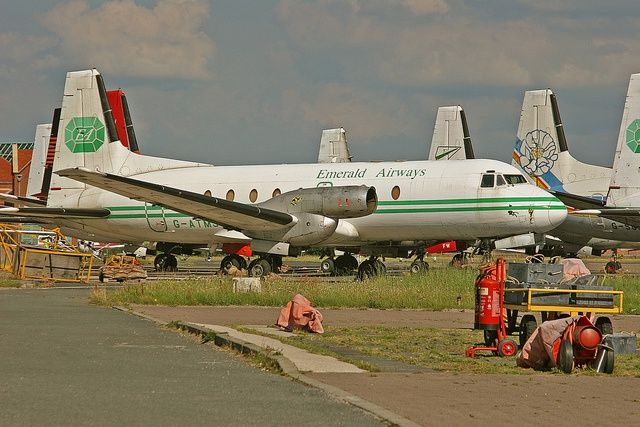Describe the objects in this image and their specific colors. I can see airplane in gray, lightgray, darkgray, and olive tones, airplane in gray, black, darkgray, and darkgreen tones, airplane in gray, darkgray, and tan tones, airplane in gray, darkgray, black, and lightgray tones, and airplane in gray and darkgray tones in this image. 